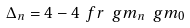Convert formula to latex. <formula><loc_0><loc_0><loc_500><loc_500>\Delta _ { n } = 4 - 4 \ f r { \ g m _ { n } } { \ g m _ { 0 } }</formula> 